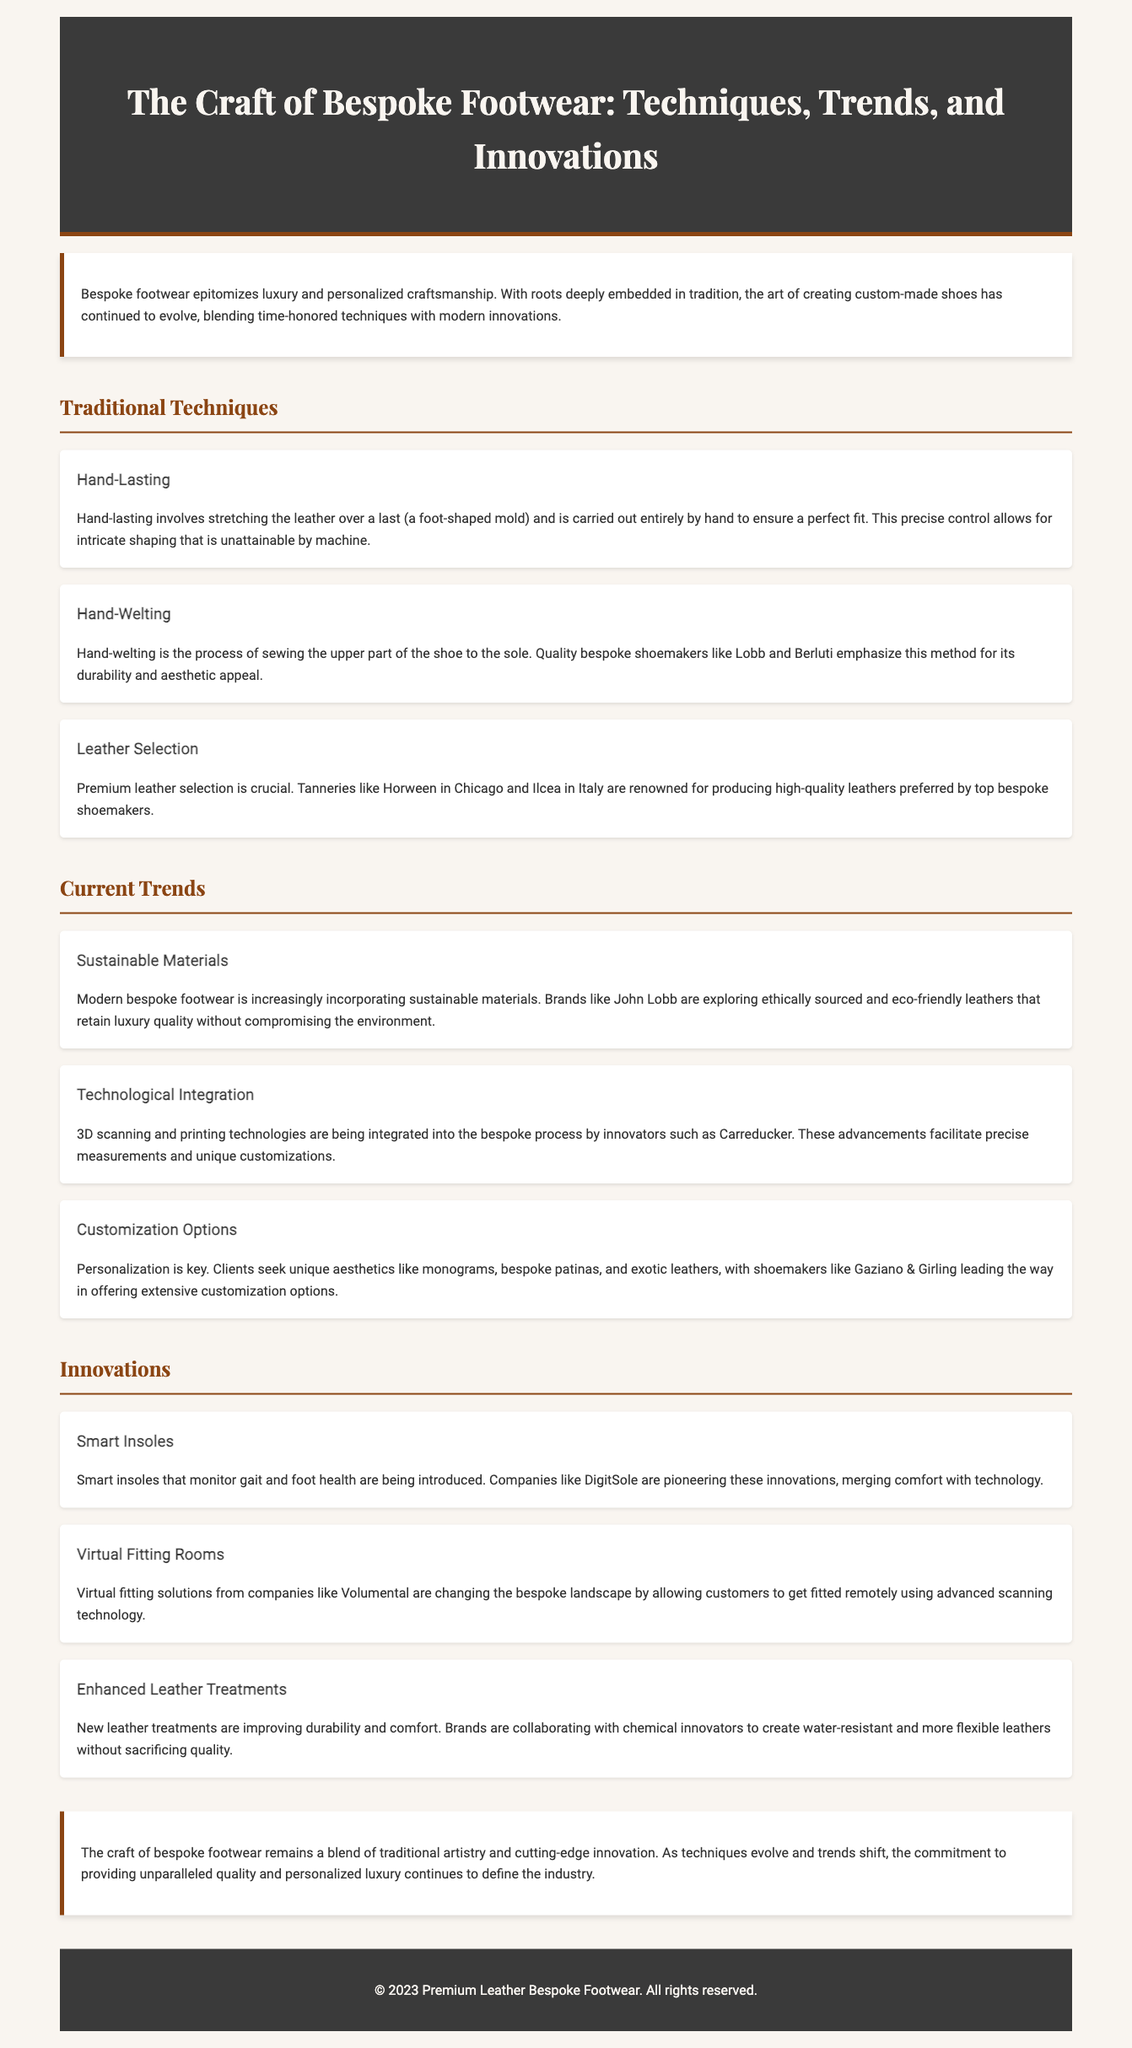What is bespoke footwear? Bespoke footwear is defined within the document as custom-made shoes that epitomize luxury and personalized craftsmanship.
Answer: custom-made shoes What is the significance of hand-lasting? Hand-lasting is explained as a traditional technique that involves stretching leather over a last, carried out by hand for a perfect fit.
Answer: perfect fit What company is known for innovative virtual fitting solutions? The document refers to Volumental as a company that provides virtual fitting solutions to enhance the bespoke experience.
Answer: Volumental Which tannery in Chicago is noted for premium leather? The document identifies Horween in Chicago as a renowned tannery for producing high-quality leathers.
Answer: Horween What trend is associated with sustainable materials? The current trend indicates that brands like John Lobb are exploring sustainable materials, specifically ethically sourced and eco-friendly leathers.
Answer: eco-friendly leathers What do smart insoles monitor? The document mentions that smart insoles are introduced to monitor gait and foot health.
Answer: gait and foot health Which shoemaker emphasizes hand-welting for durability? Lobb and Berluti are highlighted in the document for their emphasis on hand-welting due to its durability and aesthetic appeal.
Answer: Lobb and Berluti What is a key customization option that clients seek? The document states that clients desire unique aesthetics, including monograms.
Answer: monograms How does the craft of bespoke footwear blend traditional artistry? The conclusion notes that the craft blends traditional artistry with cutting-edge innovation.
Answer: cutting-edge innovation 